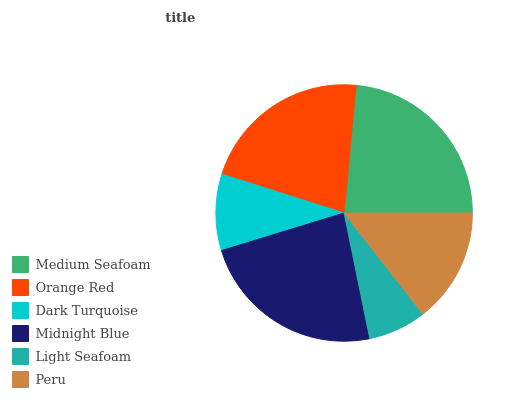Is Light Seafoam the minimum?
Answer yes or no. Yes. Is Medium Seafoam the maximum?
Answer yes or no. Yes. Is Orange Red the minimum?
Answer yes or no. No. Is Orange Red the maximum?
Answer yes or no. No. Is Medium Seafoam greater than Orange Red?
Answer yes or no. Yes. Is Orange Red less than Medium Seafoam?
Answer yes or no. Yes. Is Orange Red greater than Medium Seafoam?
Answer yes or no. No. Is Medium Seafoam less than Orange Red?
Answer yes or no. No. Is Orange Red the high median?
Answer yes or no. Yes. Is Peru the low median?
Answer yes or no. Yes. Is Peru the high median?
Answer yes or no. No. Is Medium Seafoam the low median?
Answer yes or no. No. 